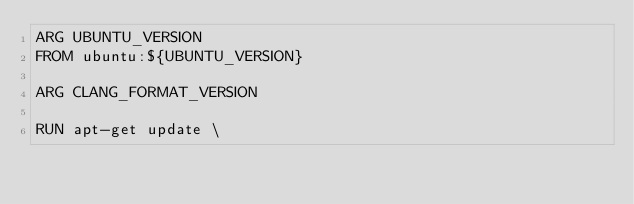<code> <loc_0><loc_0><loc_500><loc_500><_Dockerfile_>ARG UBUNTU_VERSION
FROM ubuntu:${UBUNTU_VERSION}

ARG CLANG_FORMAT_VERSION

RUN apt-get update \</code> 